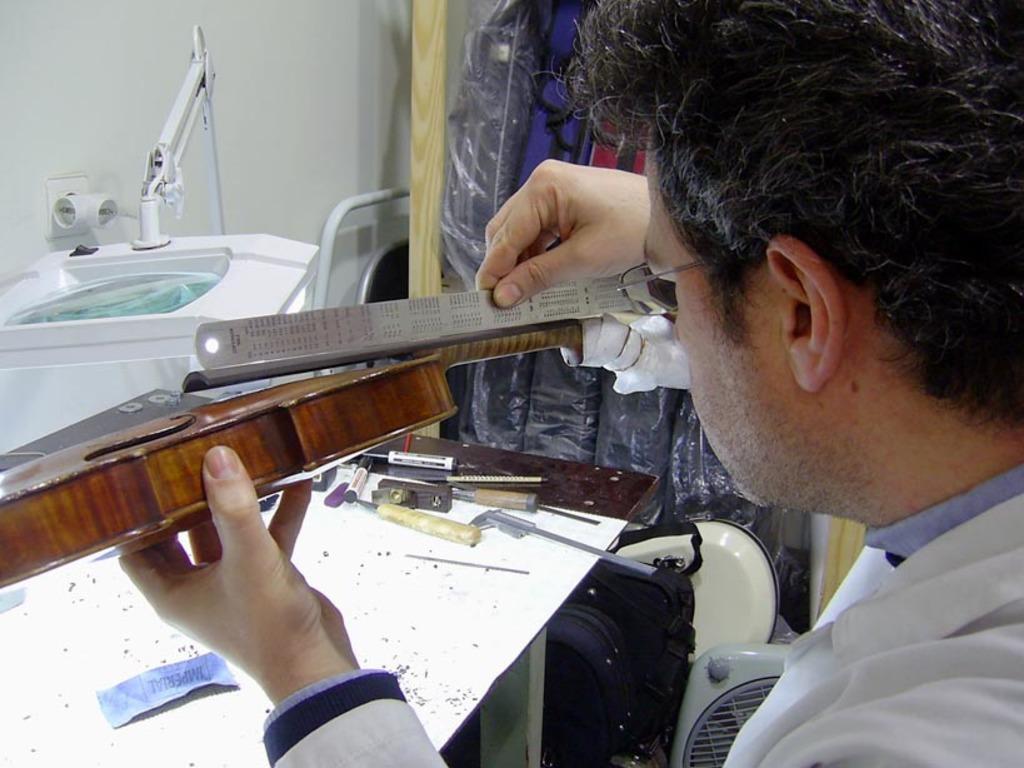In one or two sentences, can you explain what this image depicts? In this image we can see a person holding scale in one hand and an object in the other hand. In the background we can see tools and markers on the table, walls and a machine. 